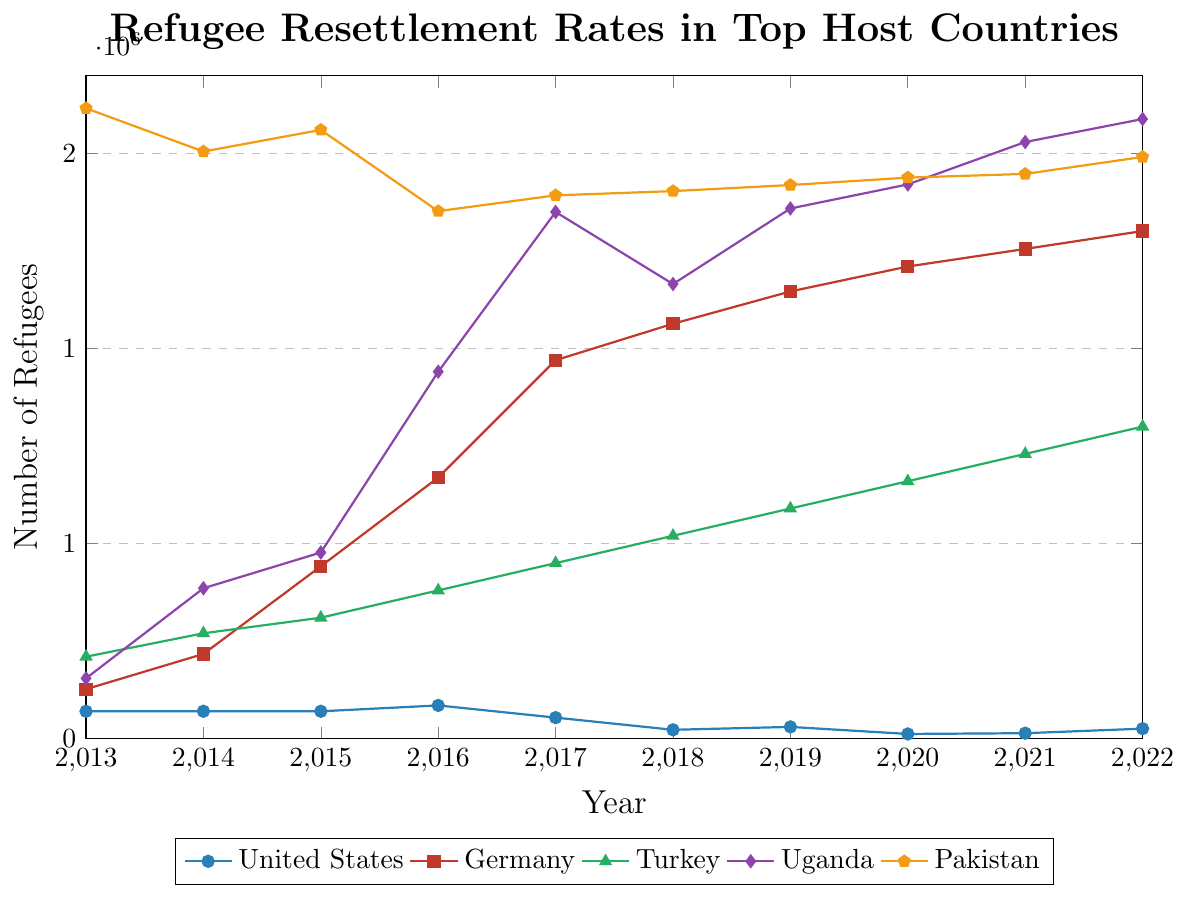Which country had the highest number of refugee resettlements in 2020? The highest point on the y-axis in 2020 represents the country with the highest resettlement number. Pakistan had the highest value.
Answer: Pakistan How did the refugee resettlement rate for the United States change from 2019 to 2020? Look at the y-values for the United States in 2019 and 2020 and note the difference. It decreased from 29916 in 2019 to 11814 in 2020.
Answer: Decreased Which country showed a continuous increase in resettlement rates from 2013 to 2022? Identify the country with a consistently upward trend across the years. Germany shows an increase every year.
Answer: Germany In which year did Uganda see its largest increase in refugee resettlement compared to the previous year? Check the difference in y-values year-over-year for Uganda and identify the largest increase. The biggest jump was from 2016 to 2017.
Answer: 2017 What was the average number of refugees resettled in Turkey over the decade? Add up Turkey's resettlement numbers for each year and then divide by the number of years (10). (210000 + 270000 + 310000 + 380000 + 450000 + 520000 + 590000 + 660000 + 730000 + 800000) / 10 = 492000
Answer: 492000 Which two countries had nearly equal resettlement rates in 2016? Compare the y-values for all countries in 2016 and find those that are close to each other. Germany and Turkey had almost similar values around 669482 and 380000 respectively.
Answer: Germany and Turkey How many more refugees did Pakistan resettle in 2017 compared to 2013? Subtract Pakistan's resettlement number in 2013 from that in 2017. 1393143 - 1616500 = -223357, so Pakistan resettled fewer refugees.
Answer: -223357 Which country had the lowest refugee resettlement rate in 2022? Identify the lowest point on the y-axis for the year 2022. The United States had the lowest number, 25465.
Answer: United States Compare the trend lines for Turkey and Uganda; which country showed a steadier increase in resettlement rates over the decade? Observe the smoothness of the trend lines for both countries. Turkey shows a steadier increase compared to Uganda, which has more fluctuations.
Answer: Turkey What is the difference between the highest and lowest refugee resettlement numbers in 2022? Identify the highest and lowest y-values for 2022 and subtract them. The highest is for Pakistan (1491601) and the lowest is for the United States (25465). 1491601 - 25465 = 1466136
Answer: 1466136 